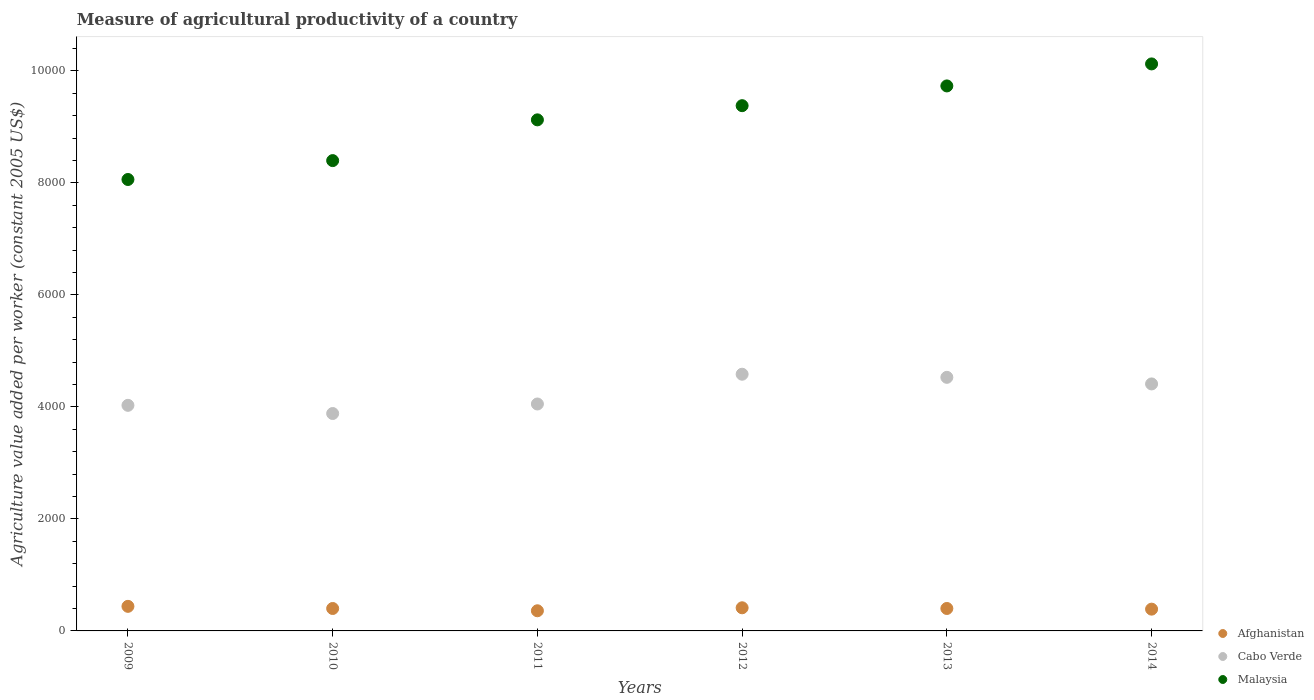How many different coloured dotlines are there?
Your answer should be compact. 3. Is the number of dotlines equal to the number of legend labels?
Make the answer very short. Yes. What is the measure of agricultural productivity in Cabo Verde in 2013?
Make the answer very short. 4527.94. Across all years, what is the maximum measure of agricultural productivity in Malaysia?
Your answer should be compact. 1.01e+04. Across all years, what is the minimum measure of agricultural productivity in Cabo Verde?
Your response must be concise. 3881.89. In which year was the measure of agricultural productivity in Cabo Verde maximum?
Keep it short and to the point. 2012. In which year was the measure of agricultural productivity in Cabo Verde minimum?
Ensure brevity in your answer.  2010. What is the total measure of agricultural productivity in Afghanistan in the graph?
Provide a short and direct response. 2401.89. What is the difference between the measure of agricultural productivity in Malaysia in 2010 and that in 2011?
Your response must be concise. -727.64. What is the difference between the measure of agricultural productivity in Afghanistan in 2014 and the measure of agricultural productivity in Cabo Verde in 2010?
Give a very brief answer. -3492.99. What is the average measure of agricultural productivity in Cabo Verde per year?
Offer a terse response. 4247.22. In the year 2014, what is the difference between the measure of agricultural productivity in Afghanistan and measure of agricultural productivity in Cabo Verde?
Provide a succinct answer. -4021.27. In how many years, is the measure of agricultural productivity in Afghanistan greater than 9200 US$?
Ensure brevity in your answer.  0. What is the ratio of the measure of agricultural productivity in Malaysia in 2012 to that in 2013?
Give a very brief answer. 0.96. Is the difference between the measure of agricultural productivity in Afghanistan in 2011 and 2013 greater than the difference between the measure of agricultural productivity in Cabo Verde in 2011 and 2013?
Your answer should be compact. Yes. What is the difference between the highest and the second highest measure of agricultural productivity in Cabo Verde?
Provide a short and direct response. 55.44. What is the difference between the highest and the lowest measure of agricultural productivity in Cabo Verde?
Give a very brief answer. 701.49. Is it the case that in every year, the sum of the measure of agricultural productivity in Afghanistan and measure of agricultural productivity in Malaysia  is greater than the measure of agricultural productivity in Cabo Verde?
Ensure brevity in your answer.  Yes. Does the measure of agricultural productivity in Afghanistan monotonically increase over the years?
Your response must be concise. No. Does the graph contain grids?
Give a very brief answer. No. What is the title of the graph?
Provide a succinct answer. Measure of agricultural productivity of a country. What is the label or title of the Y-axis?
Provide a succinct answer. Agriculture value added per worker (constant 2005 US$). What is the Agriculture value added per worker (constant 2005 US$) in Afghanistan in 2009?
Give a very brief answer. 438.8. What is the Agriculture value added per worker (constant 2005 US$) in Cabo Verde in 2009?
Provide a succinct answer. 4027.98. What is the Agriculture value added per worker (constant 2005 US$) in Malaysia in 2009?
Ensure brevity in your answer.  8060.46. What is the Agriculture value added per worker (constant 2005 US$) of Afghanistan in 2010?
Ensure brevity in your answer.  400.51. What is the Agriculture value added per worker (constant 2005 US$) of Cabo Verde in 2010?
Provide a succinct answer. 3881.89. What is the Agriculture value added per worker (constant 2005 US$) in Malaysia in 2010?
Your answer should be very brief. 8397.69. What is the Agriculture value added per worker (constant 2005 US$) of Afghanistan in 2011?
Offer a terse response. 359.87. What is the Agriculture value added per worker (constant 2005 US$) in Cabo Verde in 2011?
Offer a terse response. 4051.98. What is the Agriculture value added per worker (constant 2005 US$) of Malaysia in 2011?
Your response must be concise. 9125.33. What is the Agriculture value added per worker (constant 2005 US$) of Afghanistan in 2012?
Your response must be concise. 413.03. What is the Agriculture value added per worker (constant 2005 US$) in Cabo Verde in 2012?
Keep it short and to the point. 4583.38. What is the Agriculture value added per worker (constant 2005 US$) in Malaysia in 2012?
Keep it short and to the point. 9378.6. What is the Agriculture value added per worker (constant 2005 US$) of Afghanistan in 2013?
Provide a short and direct response. 400.79. What is the Agriculture value added per worker (constant 2005 US$) in Cabo Verde in 2013?
Offer a terse response. 4527.94. What is the Agriculture value added per worker (constant 2005 US$) in Malaysia in 2013?
Your answer should be compact. 9731.19. What is the Agriculture value added per worker (constant 2005 US$) in Afghanistan in 2014?
Give a very brief answer. 388.9. What is the Agriculture value added per worker (constant 2005 US$) in Cabo Verde in 2014?
Offer a very short reply. 4410.17. What is the Agriculture value added per worker (constant 2005 US$) of Malaysia in 2014?
Ensure brevity in your answer.  1.01e+04. Across all years, what is the maximum Agriculture value added per worker (constant 2005 US$) of Afghanistan?
Make the answer very short. 438.8. Across all years, what is the maximum Agriculture value added per worker (constant 2005 US$) of Cabo Verde?
Your answer should be compact. 4583.38. Across all years, what is the maximum Agriculture value added per worker (constant 2005 US$) in Malaysia?
Your answer should be compact. 1.01e+04. Across all years, what is the minimum Agriculture value added per worker (constant 2005 US$) in Afghanistan?
Provide a succinct answer. 359.87. Across all years, what is the minimum Agriculture value added per worker (constant 2005 US$) of Cabo Verde?
Keep it short and to the point. 3881.89. Across all years, what is the minimum Agriculture value added per worker (constant 2005 US$) of Malaysia?
Offer a very short reply. 8060.46. What is the total Agriculture value added per worker (constant 2005 US$) of Afghanistan in the graph?
Make the answer very short. 2401.89. What is the total Agriculture value added per worker (constant 2005 US$) in Cabo Verde in the graph?
Offer a very short reply. 2.55e+04. What is the total Agriculture value added per worker (constant 2005 US$) in Malaysia in the graph?
Offer a terse response. 5.48e+04. What is the difference between the Agriculture value added per worker (constant 2005 US$) in Afghanistan in 2009 and that in 2010?
Provide a short and direct response. 38.3. What is the difference between the Agriculture value added per worker (constant 2005 US$) in Cabo Verde in 2009 and that in 2010?
Provide a succinct answer. 146.09. What is the difference between the Agriculture value added per worker (constant 2005 US$) in Malaysia in 2009 and that in 2010?
Offer a terse response. -337.23. What is the difference between the Agriculture value added per worker (constant 2005 US$) of Afghanistan in 2009 and that in 2011?
Ensure brevity in your answer.  78.94. What is the difference between the Agriculture value added per worker (constant 2005 US$) in Cabo Verde in 2009 and that in 2011?
Provide a succinct answer. -24. What is the difference between the Agriculture value added per worker (constant 2005 US$) in Malaysia in 2009 and that in 2011?
Make the answer very short. -1064.87. What is the difference between the Agriculture value added per worker (constant 2005 US$) of Afghanistan in 2009 and that in 2012?
Keep it short and to the point. 25.77. What is the difference between the Agriculture value added per worker (constant 2005 US$) in Cabo Verde in 2009 and that in 2012?
Make the answer very short. -555.4. What is the difference between the Agriculture value added per worker (constant 2005 US$) of Malaysia in 2009 and that in 2012?
Give a very brief answer. -1318.14. What is the difference between the Agriculture value added per worker (constant 2005 US$) in Afghanistan in 2009 and that in 2013?
Your answer should be compact. 38.02. What is the difference between the Agriculture value added per worker (constant 2005 US$) of Cabo Verde in 2009 and that in 2013?
Offer a terse response. -499.96. What is the difference between the Agriculture value added per worker (constant 2005 US$) of Malaysia in 2009 and that in 2013?
Provide a short and direct response. -1670.73. What is the difference between the Agriculture value added per worker (constant 2005 US$) in Afghanistan in 2009 and that in 2014?
Offer a terse response. 49.91. What is the difference between the Agriculture value added per worker (constant 2005 US$) in Cabo Verde in 2009 and that in 2014?
Your answer should be compact. -382.19. What is the difference between the Agriculture value added per worker (constant 2005 US$) of Malaysia in 2009 and that in 2014?
Keep it short and to the point. -2063.68. What is the difference between the Agriculture value added per worker (constant 2005 US$) of Afghanistan in 2010 and that in 2011?
Your answer should be compact. 40.64. What is the difference between the Agriculture value added per worker (constant 2005 US$) of Cabo Verde in 2010 and that in 2011?
Provide a short and direct response. -170.1. What is the difference between the Agriculture value added per worker (constant 2005 US$) of Malaysia in 2010 and that in 2011?
Keep it short and to the point. -727.64. What is the difference between the Agriculture value added per worker (constant 2005 US$) in Afghanistan in 2010 and that in 2012?
Your answer should be very brief. -12.52. What is the difference between the Agriculture value added per worker (constant 2005 US$) of Cabo Verde in 2010 and that in 2012?
Provide a succinct answer. -701.49. What is the difference between the Agriculture value added per worker (constant 2005 US$) of Malaysia in 2010 and that in 2012?
Provide a succinct answer. -980.91. What is the difference between the Agriculture value added per worker (constant 2005 US$) in Afghanistan in 2010 and that in 2013?
Provide a succinct answer. -0.28. What is the difference between the Agriculture value added per worker (constant 2005 US$) of Cabo Verde in 2010 and that in 2013?
Ensure brevity in your answer.  -646.05. What is the difference between the Agriculture value added per worker (constant 2005 US$) of Malaysia in 2010 and that in 2013?
Your answer should be compact. -1333.5. What is the difference between the Agriculture value added per worker (constant 2005 US$) in Afghanistan in 2010 and that in 2014?
Ensure brevity in your answer.  11.61. What is the difference between the Agriculture value added per worker (constant 2005 US$) of Cabo Verde in 2010 and that in 2014?
Keep it short and to the point. -528.28. What is the difference between the Agriculture value added per worker (constant 2005 US$) in Malaysia in 2010 and that in 2014?
Your response must be concise. -1726.45. What is the difference between the Agriculture value added per worker (constant 2005 US$) of Afghanistan in 2011 and that in 2012?
Your answer should be compact. -53.16. What is the difference between the Agriculture value added per worker (constant 2005 US$) in Cabo Verde in 2011 and that in 2012?
Offer a very short reply. -531.39. What is the difference between the Agriculture value added per worker (constant 2005 US$) of Malaysia in 2011 and that in 2012?
Keep it short and to the point. -253.27. What is the difference between the Agriculture value added per worker (constant 2005 US$) in Afghanistan in 2011 and that in 2013?
Your answer should be very brief. -40.92. What is the difference between the Agriculture value added per worker (constant 2005 US$) in Cabo Verde in 2011 and that in 2013?
Offer a terse response. -475.95. What is the difference between the Agriculture value added per worker (constant 2005 US$) in Malaysia in 2011 and that in 2013?
Make the answer very short. -605.86. What is the difference between the Agriculture value added per worker (constant 2005 US$) of Afghanistan in 2011 and that in 2014?
Offer a terse response. -29.03. What is the difference between the Agriculture value added per worker (constant 2005 US$) of Cabo Verde in 2011 and that in 2014?
Give a very brief answer. -358.19. What is the difference between the Agriculture value added per worker (constant 2005 US$) of Malaysia in 2011 and that in 2014?
Ensure brevity in your answer.  -998.82. What is the difference between the Agriculture value added per worker (constant 2005 US$) in Afghanistan in 2012 and that in 2013?
Give a very brief answer. 12.24. What is the difference between the Agriculture value added per worker (constant 2005 US$) in Cabo Verde in 2012 and that in 2013?
Your answer should be very brief. 55.44. What is the difference between the Agriculture value added per worker (constant 2005 US$) in Malaysia in 2012 and that in 2013?
Offer a terse response. -352.6. What is the difference between the Agriculture value added per worker (constant 2005 US$) in Afghanistan in 2012 and that in 2014?
Your answer should be very brief. 24.13. What is the difference between the Agriculture value added per worker (constant 2005 US$) in Cabo Verde in 2012 and that in 2014?
Your answer should be very brief. 173.21. What is the difference between the Agriculture value added per worker (constant 2005 US$) in Malaysia in 2012 and that in 2014?
Provide a short and direct response. -745.55. What is the difference between the Agriculture value added per worker (constant 2005 US$) in Afghanistan in 2013 and that in 2014?
Make the answer very short. 11.89. What is the difference between the Agriculture value added per worker (constant 2005 US$) in Cabo Verde in 2013 and that in 2014?
Your answer should be compact. 117.77. What is the difference between the Agriculture value added per worker (constant 2005 US$) of Malaysia in 2013 and that in 2014?
Your answer should be compact. -392.95. What is the difference between the Agriculture value added per worker (constant 2005 US$) of Afghanistan in 2009 and the Agriculture value added per worker (constant 2005 US$) of Cabo Verde in 2010?
Your answer should be compact. -3443.08. What is the difference between the Agriculture value added per worker (constant 2005 US$) in Afghanistan in 2009 and the Agriculture value added per worker (constant 2005 US$) in Malaysia in 2010?
Give a very brief answer. -7958.89. What is the difference between the Agriculture value added per worker (constant 2005 US$) in Cabo Verde in 2009 and the Agriculture value added per worker (constant 2005 US$) in Malaysia in 2010?
Keep it short and to the point. -4369.71. What is the difference between the Agriculture value added per worker (constant 2005 US$) of Afghanistan in 2009 and the Agriculture value added per worker (constant 2005 US$) of Cabo Verde in 2011?
Your response must be concise. -3613.18. What is the difference between the Agriculture value added per worker (constant 2005 US$) in Afghanistan in 2009 and the Agriculture value added per worker (constant 2005 US$) in Malaysia in 2011?
Make the answer very short. -8686.53. What is the difference between the Agriculture value added per worker (constant 2005 US$) of Cabo Verde in 2009 and the Agriculture value added per worker (constant 2005 US$) of Malaysia in 2011?
Your answer should be compact. -5097.35. What is the difference between the Agriculture value added per worker (constant 2005 US$) of Afghanistan in 2009 and the Agriculture value added per worker (constant 2005 US$) of Cabo Verde in 2012?
Your response must be concise. -4144.57. What is the difference between the Agriculture value added per worker (constant 2005 US$) of Afghanistan in 2009 and the Agriculture value added per worker (constant 2005 US$) of Malaysia in 2012?
Offer a very short reply. -8939.8. What is the difference between the Agriculture value added per worker (constant 2005 US$) of Cabo Verde in 2009 and the Agriculture value added per worker (constant 2005 US$) of Malaysia in 2012?
Your answer should be very brief. -5350.62. What is the difference between the Agriculture value added per worker (constant 2005 US$) in Afghanistan in 2009 and the Agriculture value added per worker (constant 2005 US$) in Cabo Verde in 2013?
Provide a succinct answer. -4089.13. What is the difference between the Agriculture value added per worker (constant 2005 US$) of Afghanistan in 2009 and the Agriculture value added per worker (constant 2005 US$) of Malaysia in 2013?
Provide a short and direct response. -9292.39. What is the difference between the Agriculture value added per worker (constant 2005 US$) of Cabo Verde in 2009 and the Agriculture value added per worker (constant 2005 US$) of Malaysia in 2013?
Offer a very short reply. -5703.22. What is the difference between the Agriculture value added per worker (constant 2005 US$) of Afghanistan in 2009 and the Agriculture value added per worker (constant 2005 US$) of Cabo Verde in 2014?
Keep it short and to the point. -3971.37. What is the difference between the Agriculture value added per worker (constant 2005 US$) in Afghanistan in 2009 and the Agriculture value added per worker (constant 2005 US$) in Malaysia in 2014?
Provide a succinct answer. -9685.34. What is the difference between the Agriculture value added per worker (constant 2005 US$) of Cabo Verde in 2009 and the Agriculture value added per worker (constant 2005 US$) of Malaysia in 2014?
Keep it short and to the point. -6096.17. What is the difference between the Agriculture value added per worker (constant 2005 US$) of Afghanistan in 2010 and the Agriculture value added per worker (constant 2005 US$) of Cabo Verde in 2011?
Make the answer very short. -3651.48. What is the difference between the Agriculture value added per worker (constant 2005 US$) in Afghanistan in 2010 and the Agriculture value added per worker (constant 2005 US$) in Malaysia in 2011?
Your response must be concise. -8724.82. What is the difference between the Agriculture value added per worker (constant 2005 US$) of Cabo Verde in 2010 and the Agriculture value added per worker (constant 2005 US$) of Malaysia in 2011?
Keep it short and to the point. -5243.44. What is the difference between the Agriculture value added per worker (constant 2005 US$) in Afghanistan in 2010 and the Agriculture value added per worker (constant 2005 US$) in Cabo Verde in 2012?
Ensure brevity in your answer.  -4182.87. What is the difference between the Agriculture value added per worker (constant 2005 US$) in Afghanistan in 2010 and the Agriculture value added per worker (constant 2005 US$) in Malaysia in 2012?
Offer a terse response. -8978.09. What is the difference between the Agriculture value added per worker (constant 2005 US$) of Cabo Verde in 2010 and the Agriculture value added per worker (constant 2005 US$) of Malaysia in 2012?
Your response must be concise. -5496.71. What is the difference between the Agriculture value added per worker (constant 2005 US$) of Afghanistan in 2010 and the Agriculture value added per worker (constant 2005 US$) of Cabo Verde in 2013?
Give a very brief answer. -4127.43. What is the difference between the Agriculture value added per worker (constant 2005 US$) in Afghanistan in 2010 and the Agriculture value added per worker (constant 2005 US$) in Malaysia in 2013?
Make the answer very short. -9330.69. What is the difference between the Agriculture value added per worker (constant 2005 US$) of Cabo Verde in 2010 and the Agriculture value added per worker (constant 2005 US$) of Malaysia in 2013?
Offer a very short reply. -5849.31. What is the difference between the Agriculture value added per worker (constant 2005 US$) of Afghanistan in 2010 and the Agriculture value added per worker (constant 2005 US$) of Cabo Verde in 2014?
Make the answer very short. -4009.66. What is the difference between the Agriculture value added per worker (constant 2005 US$) in Afghanistan in 2010 and the Agriculture value added per worker (constant 2005 US$) in Malaysia in 2014?
Your answer should be compact. -9723.64. What is the difference between the Agriculture value added per worker (constant 2005 US$) in Cabo Verde in 2010 and the Agriculture value added per worker (constant 2005 US$) in Malaysia in 2014?
Provide a short and direct response. -6242.26. What is the difference between the Agriculture value added per worker (constant 2005 US$) in Afghanistan in 2011 and the Agriculture value added per worker (constant 2005 US$) in Cabo Verde in 2012?
Ensure brevity in your answer.  -4223.51. What is the difference between the Agriculture value added per worker (constant 2005 US$) of Afghanistan in 2011 and the Agriculture value added per worker (constant 2005 US$) of Malaysia in 2012?
Give a very brief answer. -9018.73. What is the difference between the Agriculture value added per worker (constant 2005 US$) of Cabo Verde in 2011 and the Agriculture value added per worker (constant 2005 US$) of Malaysia in 2012?
Provide a short and direct response. -5326.62. What is the difference between the Agriculture value added per worker (constant 2005 US$) in Afghanistan in 2011 and the Agriculture value added per worker (constant 2005 US$) in Cabo Verde in 2013?
Give a very brief answer. -4168.07. What is the difference between the Agriculture value added per worker (constant 2005 US$) of Afghanistan in 2011 and the Agriculture value added per worker (constant 2005 US$) of Malaysia in 2013?
Offer a very short reply. -9371.33. What is the difference between the Agriculture value added per worker (constant 2005 US$) in Cabo Verde in 2011 and the Agriculture value added per worker (constant 2005 US$) in Malaysia in 2013?
Provide a succinct answer. -5679.21. What is the difference between the Agriculture value added per worker (constant 2005 US$) of Afghanistan in 2011 and the Agriculture value added per worker (constant 2005 US$) of Cabo Verde in 2014?
Your answer should be very brief. -4050.3. What is the difference between the Agriculture value added per worker (constant 2005 US$) of Afghanistan in 2011 and the Agriculture value added per worker (constant 2005 US$) of Malaysia in 2014?
Offer a very short reply. -9764.28. What is the difference between the Agriculture value added per worker (constant 2005 US$) in Cabo Verde in 2011 and the Agriculture value added per worker (constant 2005 US$) in Malaysia in 2014?
Offer a very short reply. -6072.16. What is the difference between the Agriculture value added per worker (constant 2005 US$) of Afghanistan in 2012 and the Agriculture value added per worker (constant 2005 US$) of Cabo Verde in 2013?
Make the answer very short. -4114.91. What is the difference between the Agriculture value added per worker (constant 2005 US$) in Afghanistan in 2012 and the Agriculture value added per worker (constant 2005 US$) in Malaysia in 2013?
Provide a short and direct response. -9318.16. What is the difference between the Agriculture value added per worker (constant 2005 US$) in Cabo Verde in 2012 and the Agriculture value added per worker (constant 2005 US$) in Malaysia in 2013?
Make the answer very short. -5147.82. What is the difference between the Agriculture value added per worker (constant 2005 US$) of Afghanistan in 2012 and the Agriculture value added per worker (constant 2005 US$) of Cabo Verde in 2014?
Your answer should be compact. -3997.14. What is the difference between the Agriculture value added per worker (constant 2005 US$) in Afghanistan in 2012 and the Agriculture value added per worker (constant 2005 US$) in Malaysia in 2014?
Offer a very short reply. -9711.12. What is the difference between the Agriculture value added per worker (constant 2005 US$) in Cabo Verde in 2012 and the Agriculture value added per worker (constant 2005 US$) in Malaysia in 2014?
Provide a succinct answer. -5540.77. What is the difference between the Agriculture value added per worker (constant 2005 US$) in Afghanistan in 2013 and the Agriculture value added per worker (constant 2005 US$) in Cabo Verde in 2014?
Offer a terse response. -4009.38. What is the difference between the Agriculture value added per worker (constant 2005 US$) in Afghanistan in 2013 and the Agriculture value added per worker (constant 2005 US$) in Malaysia in 2014?
Make the answer very short. -9723.36. What is the difference between the Agriculture value added per worker (constant 2005 US$) in Cabo Verde in 2013 and the Agriculture value added per worker (constant 2005 US$) in Malaysia in 2014?
Offer a very short reply. -5596.21. What is the average Agriculture value added per worker (constant 2005 US$) in Afghanistan per year?
Make the answer very short. 400.32. What is the average Agriculture value added per worker (constant 2005 US$) in Cabo Verde per year?
Give a very brief answer. 4247.22. What is the average Agriculture value added per worker (constant 2005 US$) in Malaysia per year?
Provide a succinct answer. 9136.24. In the year 2009, what is the difference between the Agriculture value added per worker (constant 2005 US$) in Afghanistan and Agriculture value added per worker (constant 2005 US$) in Cabo Verde?
Your response must be concise. -3589.18. In the year 2009, what is the difference between the Agriculture value added per worker (constant 2005 US$) of Afghanistan and Agriculture value added per worker (constant 2005 US$) of Malaysia?
Your response must be concise. -7621.66. In the year 2009, what is the difference between the Agriculture value added per worker (constant 2005 US$) of Cabo Verde and Agriculture value added per worker (constant 2005 US$) of Malaysia?
Keep it short and to the point. -4032.48. In the year 2010, what is the difference between the Agriculture value added per worker (constant 2005 US$) of Afghanistan and Agriculture value added per worker (constant 2005 US$) of Cabo Verde?
Provide a succinct answer. -3481.38. In the year 2010, what is the difference between the Agriculture value added per worker (constant 2005 US$) in Afghanistan and Agriculture value added per worker (constant 2005 US$) in Malaysia?
Provide a short and direct response. -7997.19. In the year 2010, what is the difference between the Agriculture value added per worker (constant 2005 US$) of Cabo Verde and Agriculture value added per worker (constant 2005 US$) of Malaysia?
Your answer should be compact. -4515.81. In the year 2011, what is the difference between the Agriculture value added per worker (constant 2005 US$) of Afghanistan and Agriculture value added per worker (constant 2005 US$) of Cabo Verde?
Provide a short and direct response. -3692.12. In the year 2011, what is the difference between the Agriculture value added per worker (constant 2005 US$) of Afghanistan and Agriculture value added per worker (constant 2005 US$) of Malaysia?
Provide a succinct answer. -8765.46. In the year 2011, what is the difference between the Agriculture value added per worker (constant 2005 US$) in Cabo Verde and Agriculture value added per worker (constant 2005 US$) in Malaysia?
Keep it short and to the point. -5073.35. In the year 2012, what is the difference between the Agriculture value added per worker (constant 2005 US$) of Afghanistan and Agriculture value added per worker (constant 2005 US$) of Cabo Verde?
Keep it short and to the point. -4170.35. In the year 2012, what is the difference between the Agriculture value added per worker (constant 2005 US$) of Afghanistan and Agriculture value added per worker (constant 2005 US$) of Malaysia?
Your answer should be very brief. -8965.57. In the year 2012, what is the difference between the Agriculture value added per worker (constant 2005 US$) in Cabo Verde and Agriculture value added per worker (constant 2005 US$) in Malaysia?
Your response must be concise. -4795.22. In the year 2013, what is the difference between the Agriculture value added per worker (constant 2005 US$) in Afghanistan and Agriculture value added per worker (constant 2005 US$) in Cabo Verde?
Your answer should be very brief. -4127.15. In the year 2013, what is the difference between the Agriculture value added per worker (constant 2005 US$) of Afghanistan and Agriculture value added per worker (constant 2005 US$) of Malaysia?
Your answer should be very brief. -9330.41. In the year 2013, what is the difference between the Agriculture value added per worker (constant 2005 US$) in Cabo Verde and Agriculture value added per worker (constant 2005 US$) in Malaysia?
Offer a terse response. -5203.26. In the year 2014, what is the difference between the Agriculture value added per worker (constant 2005 US$) of Afghanistan and Agriculture value added per worker (constant 2005 US$) of Cabo Verde?
Your answer should be very brief. -4021.27. In the year 2014, what is the difference between the Agriculture value added per worker (constant 2005 US$) in Afghanistan and Agriculture value added per worker (constant 2005 US$) in Malaysia?
Your response must be concise. -9735.25. In the year 2014, what is the difference between the Agriculture value added per worker (constant 2005 US$) in Cabo Verde and Agriculture value added per worker (constant 2005 US$) in Malaysia?
Provide a succinct answer. -5713.98. What is the ratio of the Agriculture value added per worker (constant 2005 US$) in Afghanistan in 2009 to that in 2010?
Provide a short and direct response. 1.1. What is the ratio of the Agriculture value added per worker (constant 2005 US$) in Cabo Verde in 2009 to that in 2010?
Your answer should be compact. 1.04. What is the ratio of the Agriculture value added per worker (constant 2005 US$) in Malaysia in 2009 to that in 2010?
Provide a succinct answer. 0.96. What is the ratio of the Agriculture value added per worker (constant 2005 US$) of Afghanistan in 2009 to that in 2011?
Keep it short and to the point. 1.22. What is the ratio of the Agriculture value added per worker (constant 2005 US$) of Cabo Verde in 2009 to that in 2011?
Offer a very short reply. 0.99. What is the ratio of the Agriculture value added per worker (constant 2005 US$) of Malaysia in 2009 to that in 2011?
Offer a very short reply. 0.88. What is the ratio of the Agriculture value added per worker (constant 2005 US$) of Afghanistan in 2009 to that in 2012?
Provide a short and direct response. 1.06. What is the ratio of the Agriculture value added per worker (constant 2005 US$) in Cabo Verde in 2009 to that in 2012?
Keep it short and to the point. 0.88. What is the ratio of the Agriculture value added per worker (constant 2005 US$) of Malaysia in 2009 to that in 2012?
Your answer should be compact. 0.86. What is the ratio of the Agriculture value added per worker (constant 2005 US$) of Afghanistan in 2009 to that in 2013?
Your answer should be very brief. 1.09. What is the ratio of the Agriculture value added per worker (constant 2005 US$) of Cabo Verde in 2009 to that in 2013?
Your answer should be compact. 0.89. What is the ratio of the Agriculture value added per worker (constant 2005 US$) in Malaysia in 2009 to that in 2013?
Your answer should be very brief. 0.83. What is the ratio of the Agriculture value added per worker (constant 2005 US$) of Afghanistan in 2009 to that in 2014?
Your answer should be very brief. 1.13. What is the ratio of the Agriculture value added per worker (constant 2005 US$) of Cabo Verde in 2009 to that in 2014?
Ensure brevity in your answer.  0.91. What is the ratio of the Agriculture value added per worker (constant 2005 US$) of Malaysia in 2009 to that in 2014?
Offer a very short reply. 0.8. What is the ratio of the Agriculture value added per worker (constant 2005 US$) of Afghanistan in 2010 to that in 2011?
Ensure brevity in your answer.  1.11. What is the ratio of the Agriculture value added per worker (constant 2005 US$) of Cabo Verde in 2010 to that in 2011?
Your answer should be compact. 0.96. What is the ratio of the Agriculture value added per worker (constant 2005 US$) in Malaysia in 2010 to that in 2011?
Your answer should be very brief. 0.92. What is the ratio of the Agriculture value added per worker (constant 2005 US$) of Afghanistan in 2010 to that in 2012?
Your answer should be very brief. 0.97. What is the ratio of the Agriculture value added per worker (constant 2005 US$) of Cabo Verde in 2010 to that in 2012?
Give a very brief answer. 0.85. What is the ratio of the Agriculture value added per worker (constant 2005 US$) of Malaysia in 2010 to that in 2012?
Your response must be concise. 0.9. What is the ratio of the Agriculture value added per worker (constant 2005 US$) in Afghanistan in 2010 to that in 2013?
Your answer should be very brief. 1. What is the ratio of the Agriculture value added per worker (constant 2005 US$) of Cabo Verde in 2010 to that in 2013?
Keep it short and to the point. 0.86. What is the ratio of the Agriculture value added per worker (constant 2005 US$) of Malaysia in 2010 to that in 2013?
Provide a succinct answer. 0.86. What is the ratio of the Agriculture value added per worker (constant 2005 US$) in Afghanistan in 2010 to that in 2014?
Provide a short and direct response. 1.03. What is the ratio of the Agriculture value added per worker (constant 2005 US$) of Cabo Verde in 2010 to that in 2014?
Your response must be concise. 0.88. What is the ratio of the Agriculture value added per worker (constant 2005 US$) in Malaysia in 2010 to that in 2014?
Make the answer very short. 0.83. What is the ratio of the Agriculture value added per worker (constant 2005 US$) of Afghanistan in 2011 to that in 2012?
Ensure brevity in your answer.  0.87. What is the ratio of the Agriculture value added per worker (constant 2005 US$) in Cabo Verde in 2011 to that in 2012?
Provide a short and direct response. 0.88. What is the ratio of the Agriculture value added per worker (constant 2005 US$) of Afghanistan in 2011 to that in 2013?
Keep it short and to the point. 0.9. What is the ratio of the Agriculture value added per worker (constant 2005 US$) of Cabo Verde in 2011 to that in 2013?
Your answer should be compact. 0.89. What is the ratio of the Agriculture value added per worker (constant 2005 US$) in Malaysia in 2011 to that in 2013?
Offer a very short reply. 0.94. What is the ratio of the Agriculture value added per worker (constant 2005 US$) in Afghanistan in 2011 to that in 2014?
Give a very brief answer. 0.93. What is the ratio of the Agriculture value added per worker (constant 2005 US$) in Cabo Verde in 2011 to that in 2014?
Your answer should be compact. 0.92. What is the ratio of the Agriculture value added per worker (constant 2005 US$) of Malaysia in 2011 to that in 2014?
Your response must be concise. 0.9. What is the ratio of the Agriculture value added per worker (constant 2005 US$) of Afghanistan in 2012 to that in 2013?
Keep it short and to the point. 1.03. What is the ratio of the Agriculture value added per worker (constant 2005 US$) in Cabo Verde in 2012 to that in 2013?
Your answer should be very brief. 1.01. What is the ratio of the Agriculture value added per worker (constant 2005 US$) in Malaysia in 2012 to that in 2013?
Give a very brief answer. 0.96. What is the ratio of the Agriculture value added per worker (constant 2005 US$) in Afghanistan in 2012 to that in 2014?
Give a very brief answer. 1.06. What is the ratio of the Agriculture value added per worker (constant 2005 US$) in Cabo Verde in 2012 to that in 2014?
Your answer should be very brief. 1.04. What is the ratio of the Agriculture value added per worker (constant 2005 US$) of Malaysia in 2012 to that in 2014?
Offer a terse response. 0.93. What is the ratio of the Agriculture value added per worker (constant 2005 US$) in Afghanistan in 2013 to that in 2014?
Provide a short and direct response. 1.03. What is the ratio of the Agriculture value added per worker (constant 2005 US$) of Cabo Verde in 2013 to that in 2014?
Ensure brevity in your answer.  1.03. What is the ratio of the Agriculture value added per worker (constant 2005 US$) in Malaysia in 2013 to that in 2014?
Make the answer very short. 0.96. What is the difference between the highest and the second highest Agriculture value added per worker (constant 2005 US$) of Afghanistan?
Your response must be concise. 25.77. What is the difference between the highest and the second highest Agriculture value added per worker (constant 2005 US$) of Cabo Verde?
Ensure brevity in your answer.  55.44. What is the difference between the highest and the second highest Agriculture value added per worker (constant 2005 US$) in Malaysia?
Make the answer very short. 392.95. What is the difference between the highest and the lowest Agriculture value added per worker (constant 2005 US$) in Afghanistan?
Make the answer very short. 78.94. What is the difference between the highest and the lowest Agriculture value added per worker (constant 2005 US$) of Cabo Verde?
Offer a terse response. 701.49. What is the difference between the highest and the lowest Agriculture value added per worker (constant 2005 US$) in Malaysia?
Your response must be concise. 2063.68. 